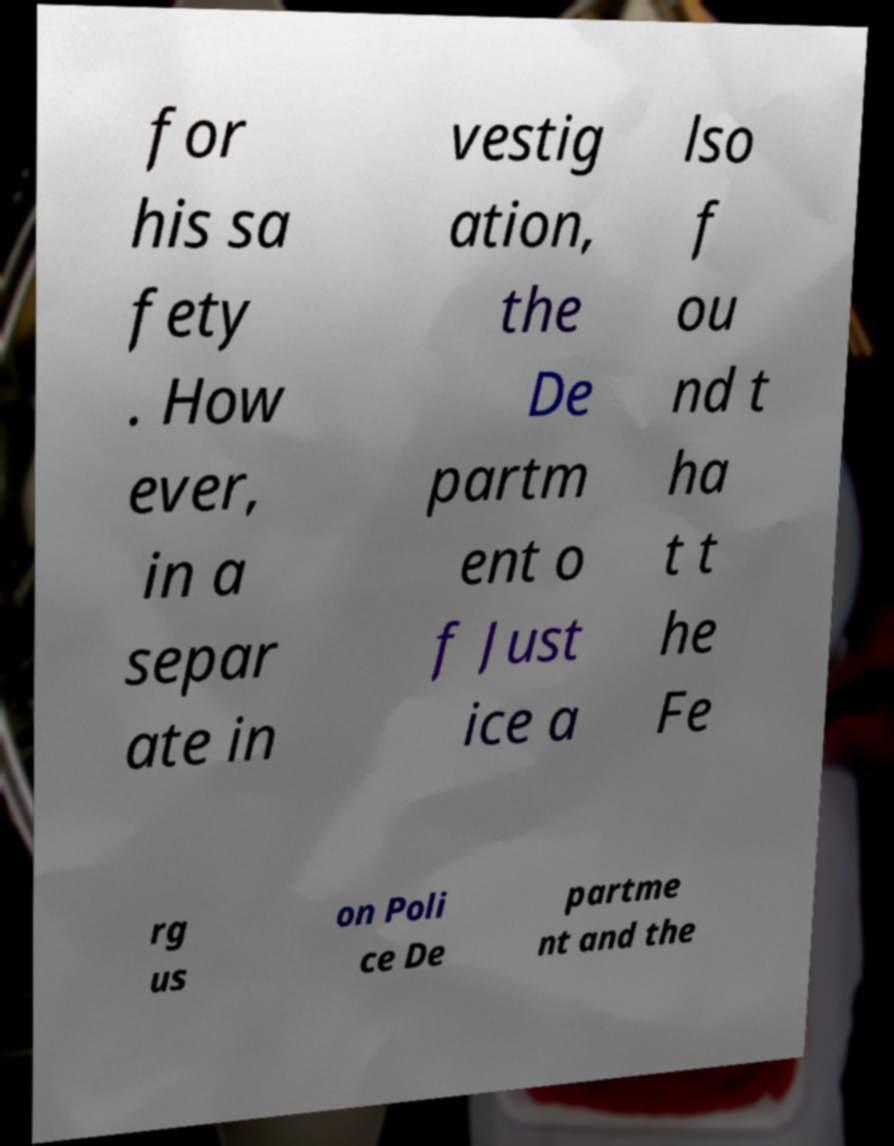Can you accurately transcribe the text from the provided image for me? for his sa fety . How ever, in a separ ate in vestig ation, the De partm ent o f Just ice a lso f ou nd t ha t t he Fe rg us on Poli ce De partme nt and the 